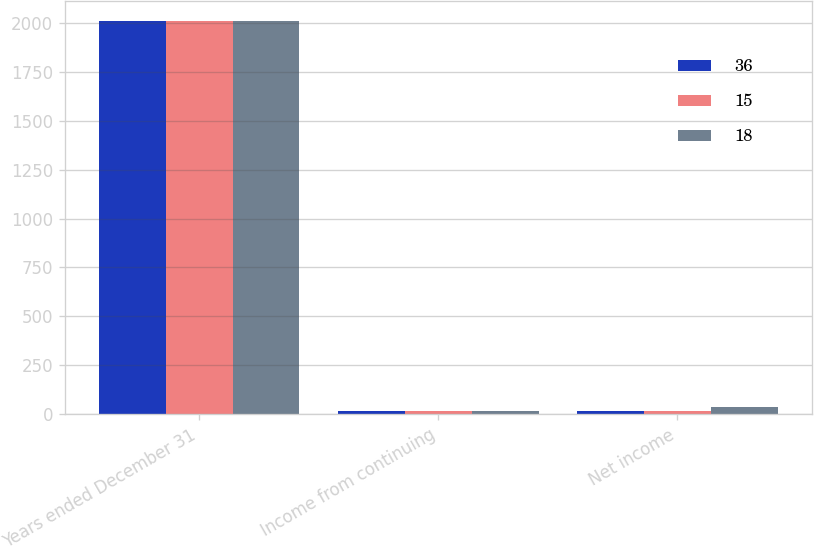Convert chart to OTSL. <chart><loc_0><loc_0><loc_500><loc_500><stacked_bar_chart><ecel><fcel>Years ended December 31<fcel>Income from continuing<fcel>Net income<nl><fcel>36<fcel>2010<fcel>15<fcel>15<nl><fcel>15<fcel>2009<fcel>15<fcel>18<nl><fcel>18<fcel>2008<fcel>15<fcel>36<nl></chart> 